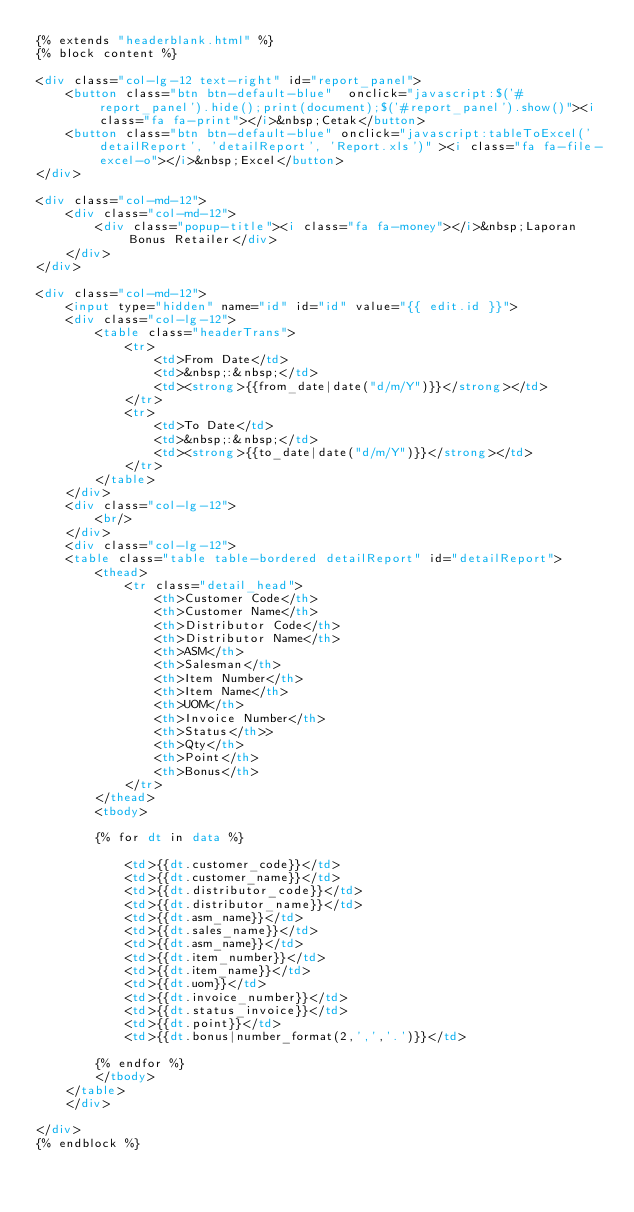Convert code to text. <code><loc_0><loc_0><loc_500><loc_500><_HTML_>{% extends "headerblank.html" %}
{% block content %}

<div class="col-lg-12 text-right" id="report_panel">
    <button class="btn btn-default-blue"  onclick="javascript:$('#report_panel').hide();print(document);$('#report_panel').show()"><i class="fa fa-print"></i>&nbsp;Cetak</button>
    <button class="btn btn-default-blue" onclick="javascript:tableToExcel('detailReport', 'detailReport', 'Report.xls')" ><i class="fa fa-file-excel-o"></i>&nbsp;Excel</button>
</div>

<div class="col-md-12">
    <div class="col-md-12">
        <div class="popup-title"><i class="fa fa-money"></i>&nbsp;Laporan Bonus Retailer</div>
    </div>
</div>

<div class="col-md-12">
    <input type="hidden" name="id" id="id" value="{{ edit.id }}">
    <div class="col-lg-12">
        <table class="headerTrans">
            <tr>
                <td>From Date</td>
                <td>&nbsp;:&nbsp;</td>
                <td><strong>{{from_date|date("d/m/Y")}}</strong></td>
            </tr>
            <tr>
                <td>To Date</td>
                <td>&nbsp;:&nbsp;</td>
                <td><strong>{{to_date|date("d/m/Y")}}</strong></td>
            </tr>
        </table>
    </div>
    <div class="col-lg-12">
        <br/>
    </div>
    <div class="col-lg-12">
    <table class="table table-bordered detailReport" id="detailReport">
        <thead>
            <tr class="detail_head">
                <th>Customer Code</th>
                <th>Customer Name</th>
                <th>Distributor Code</th>
                <th>Distributor Name</th>   
                <th>ASM</th>
                <th>Salesman</th>
                <th>Item Number</th>
                <th>Item Name</th>
                <th>UOM</th>
                <th>Invoice Number</th>
                <th>Status</th>>
                <th>Qty</th>
                <th>Point</th>
                <th>Bonus</th>   
            </tr>    
        </thead>
        <tbody>
            
        {% for dt in data %}                  

            <td>{{dt.customer_code}}</td>
            <td>{{dt.customer_name}}</td>
            <td>{{dt.distributor_code}}</td>
            <td>{{dt.distributor_name}}</td>
            <td>{{dt.asm_name}}</td>
            <td>{{dt.sales_name}}</td>
            <td>{{dt.asm_name}}</td>
            <td>{{dt.item_number}}</td>
            <td>{{dt.item_name}}</td>
            <td>{{dt.uom}}</td>
            <td>{{dt.invoice_number}}</td>
            <td>{{dt.status_invoice}}</td>
            <td>{{dt.point}}</td>
            <td>{{dt.bonus|number_format(2,',','.')}}</td>
            
        {% endfor %}
        </tbody>
    </table>
    </div>  
      
</div>
{% endblock %}
</code> 